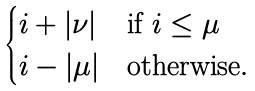<formula> <loc_0><loc_0><loc_500><loc_500>\begin{cases} i + | \nu | & \text {if $i\leq \mu$} \\ i - | \mu | & \text {otherwise} . \end{cases}</formula> 